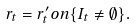Convert formula to latex. <formula><loc_0><loc_0><loc_500><loc_500>r _ { t } = r _ { t } ^ { \prime } o n \{ I _ { t } \not = \emptyset \} .</formula> 